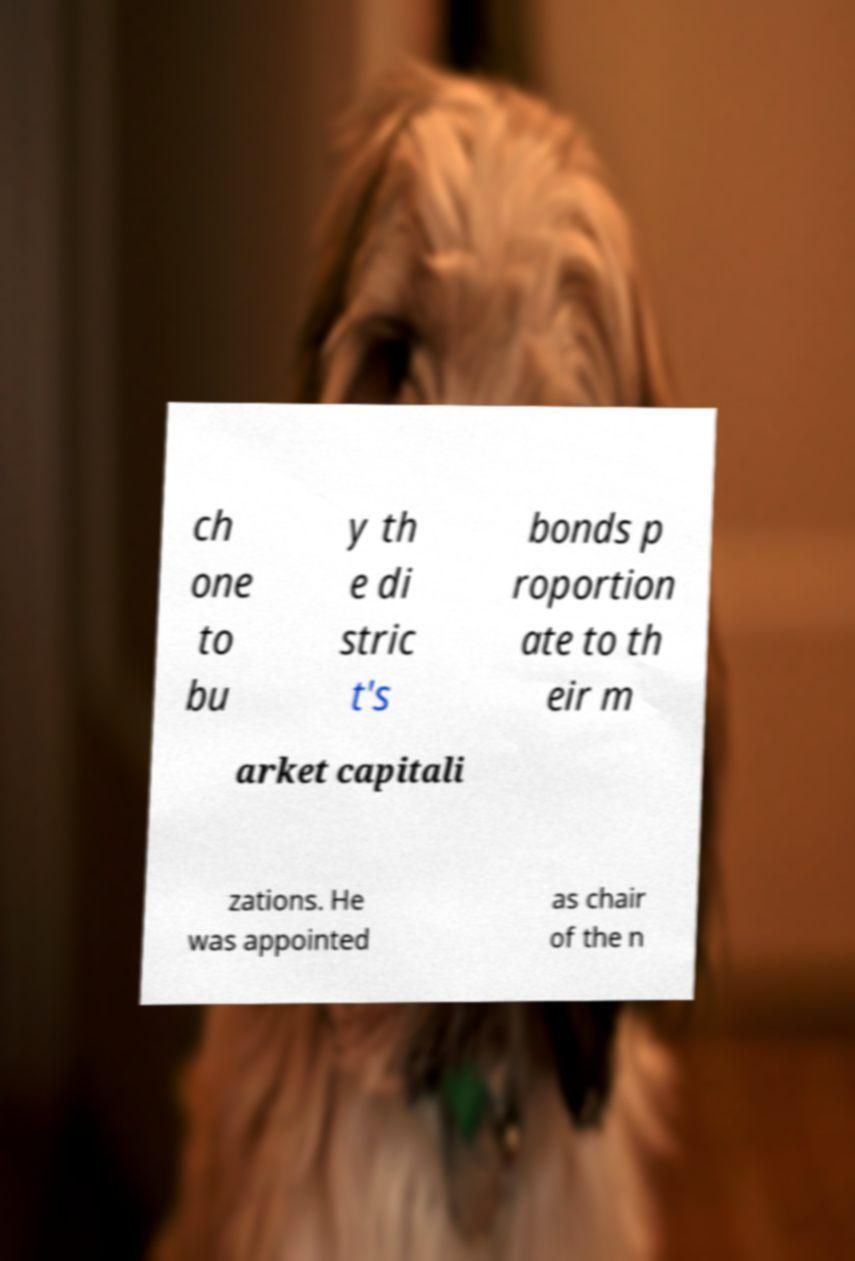Can you accurately transcribe the text from the provided image for me? ch one to bu y th e di stric t's bonds p roportion ate to th eir m arket capitali zations. He was appointed as chair of the n 